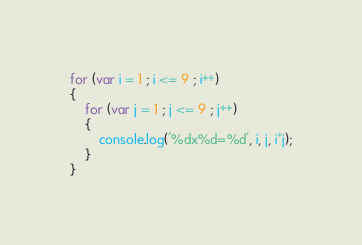<code> <loc_0><loc_0><loc_500><loc_500><_JavaScript_>for (var i = 1 ; i <= 9 ; i++)
{
	for (var j = 1 ; j <= 9 ; j++)
	{
		console.log('%dx%d=%d', i, j, i*j);
	}
}</code> 